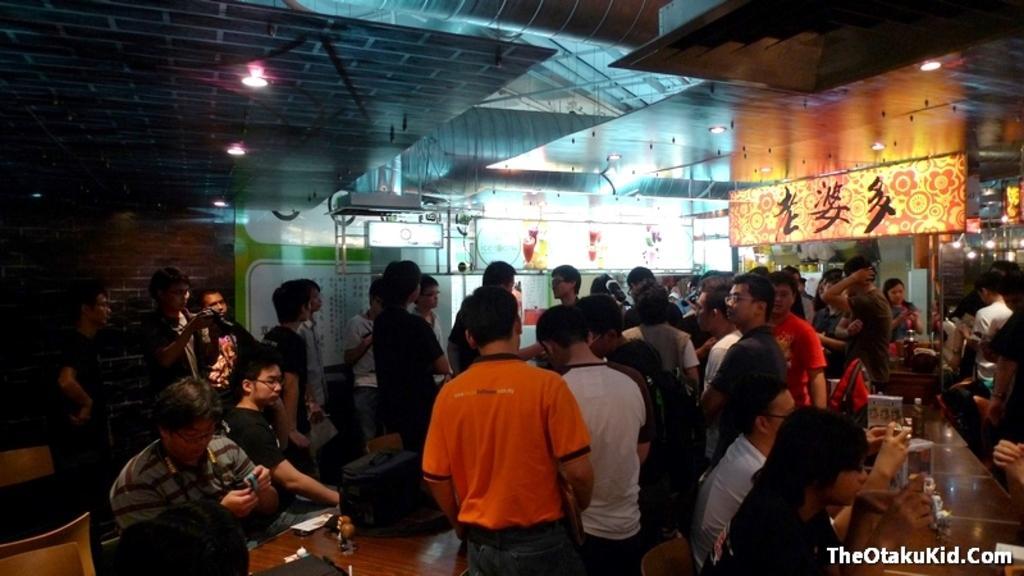Please provide a concise description of this image. In this image we can see people are sitting in front of the brown table. Behind them we can see people are standing. To the right side of the image one banner is there with some text written on it. 